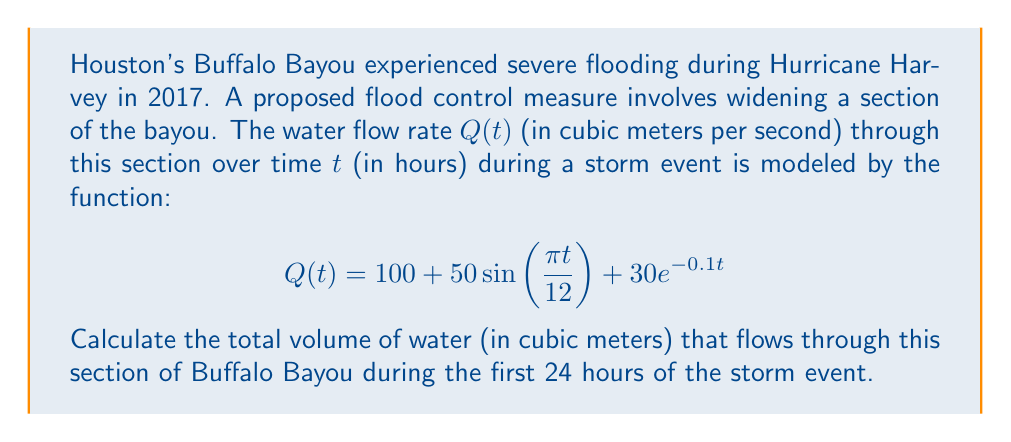What is the answer to this math problem? To solve this problem, we need to integrate the flow rate function $Q(t)$ over the given time interval. The steps are as follows:

1) The total volume of water is given by the definite integral of $Q(t)$ from $t=0$ to $t=24$:

   $$V = \int_0^{24} Q(t) dt$$

2) Substituting the given function for $Q(t)$:

   $$V = \int_0^{24} (100 + 50\sin(\frac{\pi t}{12}) + 30e^{-0.1t}) dt$$

3) We can split this into three integrals:

   $$V = \int_0^{24} 100 dt + \int_0^{24} 50\sin(\frac{\pi t}{12}) dt + \int_0^{24} 30e^{-0.1t} dt$$

4) Solving each integral:
   
   a) $\int_0^{24} 100 dt = 100t \big|_0^{24} = 2400$
   
   b) $\int_0^{24} 50\sin(\frac{\pi t}{12}) dt = -\frac{600}{\pi}\cos(\frac{\pi t}{12}) \big|_0^{24} = -\frac{600}{\pi}(\cos(2\pi) - 1) = 0$
   
   c) $\int_0^{24} 30e^{-0.1t} dt = -300e^{-0.1t} \big|_0^{24} = -300(e^{-2.4} - 1) \approx 270.67$

5) Sum the results:

   $$V = 2400 + 0 + 270.67 = 2670.67$$

Therefore, the total volume of water flowing through this section of Buffalo Bayou during the first 24 hours of the storm event is approximately 2670.67 cubic meters.
Answer: 2670.67 cubic meters 